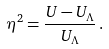Convert formula to latex. <formula><loc_0><loc_0><loc_500><loc_500>\eta ^ { 2 } = \frac { U - U _ { \Lambda } } { U _ { \Lambda } } \, .</formula> 